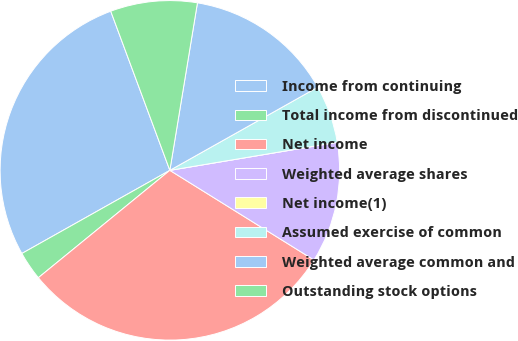<chart> <loc_0><loc_0><loc_500><loc_500><pie_chart><fcel>Income from continuing<fcel>Total income from discontinued<fcel>Net income<fcel>Weighted average shares<fcel>Net income(1)<fcel>Assumed exercise of common<fcel>Weighted average common and<fcel>Outstanding stock options<nl><fcel>27.49%<fcel>2.75%<fcel>30.25%<fcel>11.5%<fcel>0.0%<fcel>5.51%<fcel>14.25%<fcel>8.26%<nl></chart> 